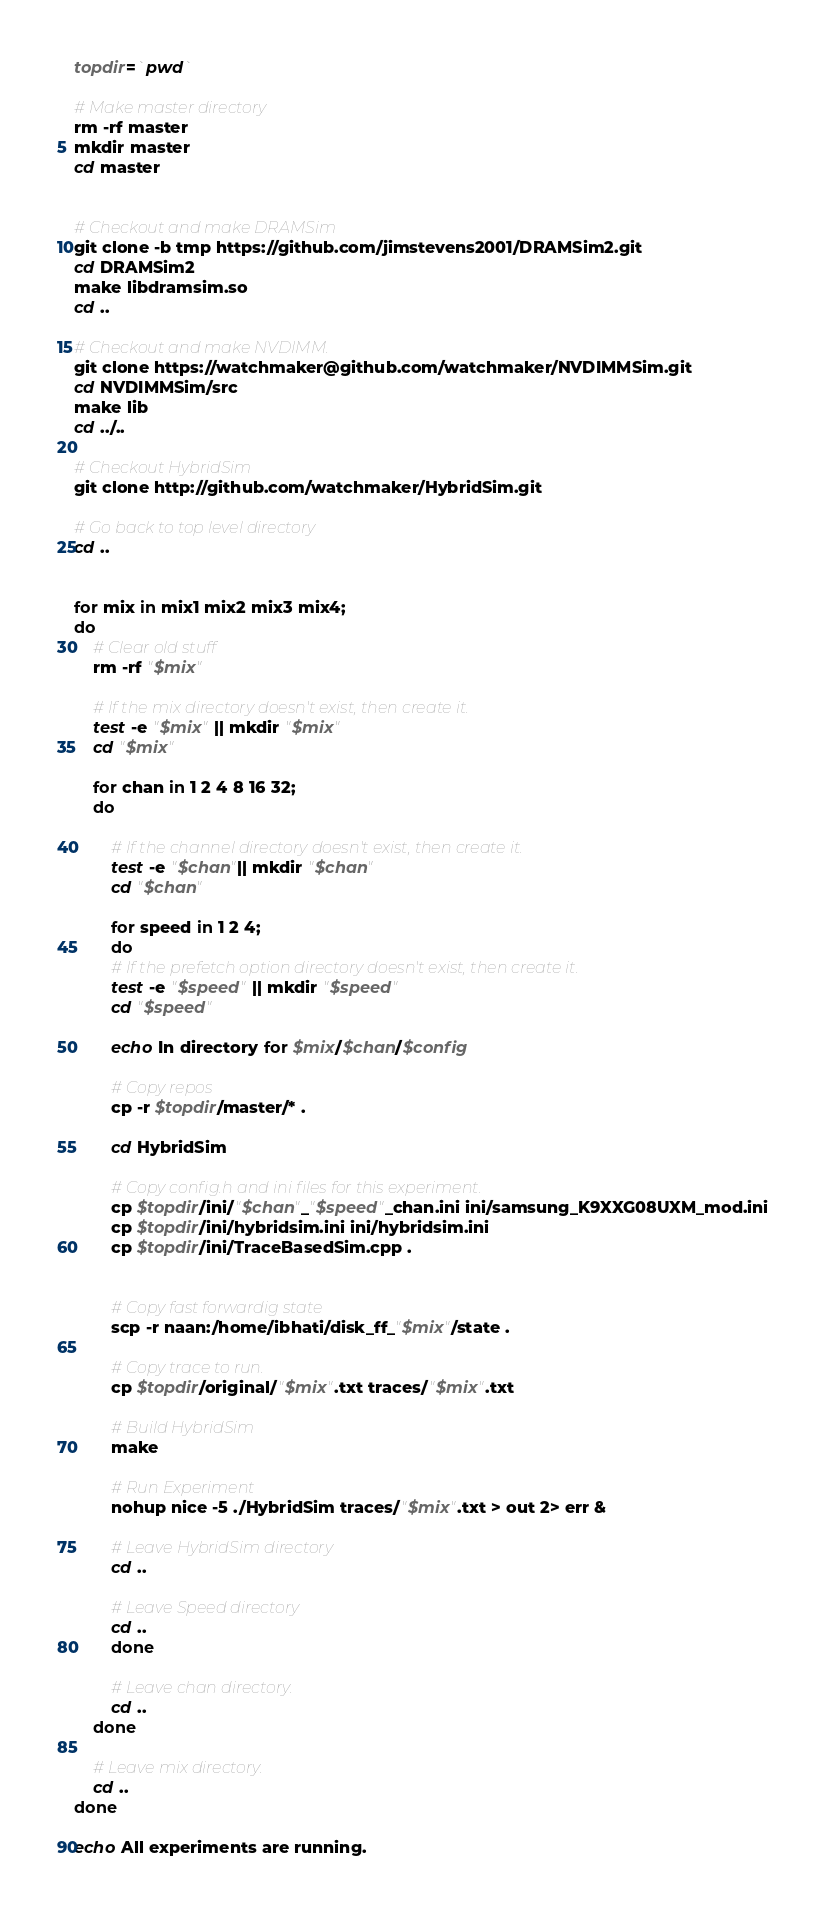<code> <loc_0><loc_0><loc_500><loc_500><_Bash_>topdir=`pwd`

# Make master directory
rm -rf master
mkdir master
cd master


# Checkout and make DRAMSim
git clone -b tmp https://github.com/jimstevens2001/DRAMSim2.git
cd DRAMSim2
make libdramsim.so
cd ..

# Checkout and make NVDIMM.
git clone https://watchmaker@github.com/watchmaker/NVDIMMSim.git
cd NVDIMMSim/src
make lib
cd ../..

# Checkout HybridSim
git clone http://github.com/watchmaker/HybridSim.git

# Go back to top level directory
cd ..


for mix in mix1 mix2 mix3 mix4;
do
	# Clear old stuff
	rm -rf "$mix"

	# If the mix directory doesn't exist, then create it.
	test -e "$mix" || mkdir "$mix"
	cd "$mix"

	for chan in 1 2 4 8 16 32;
	do

	    # If the channel directory doesn't exist, then create it.
	    test -e "$chan"|| mkdir "$chan"
	    cd "$chan"

	    for speed in 1 2 4;
	    do
		# If the prefetch option directory doesn't exist, then create it.
		test -e "$speed" || mkdir "$speed"
		cd "$speed"
			
		echo In directory for $mix/$chan/$config

		# Copy repos
		cp -r $topdir/master/* .

		cd HybridSim

		# Copy config.h and ini files for this experiment.
		cp $topdir/ini/"$chan"_"$speed"_chan.ini ini/samsung_K9XXG08UXM_mod.ini
		cp $topdir/ini/hybridsim.ini ini/hybridsim.ini
		cp $topdir/ini/TraceBasedSim.cpp .
		
		
		# Copy fast forwardig state		
		scp -r naan:/home/ibhati/disk_ff_"$mix"/state .

		# Copy trace to run.
		cp $topdir/original/"$mix".txt traces/"$mix".txt

		# Build HybridSim
		make

		# Run Experiment
		nohup nice -5 ./HybridSim traces/"$mix".txt > out 2> err &

		# Leave HybridSim directory
		cd ..
		
		# Leave Speed directory
		cd ..
	    done

	    # Leave chan directory.
	    cd ..
	done

	# Leave mix directory.
	cd ..
done

echo All experiments are running.
</code> 